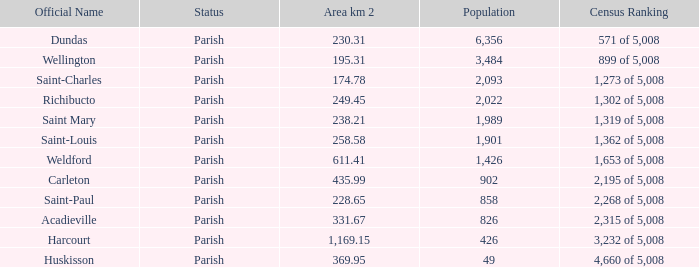For saint-paul parish, if it encompasses an area of more than 22 0.0. 